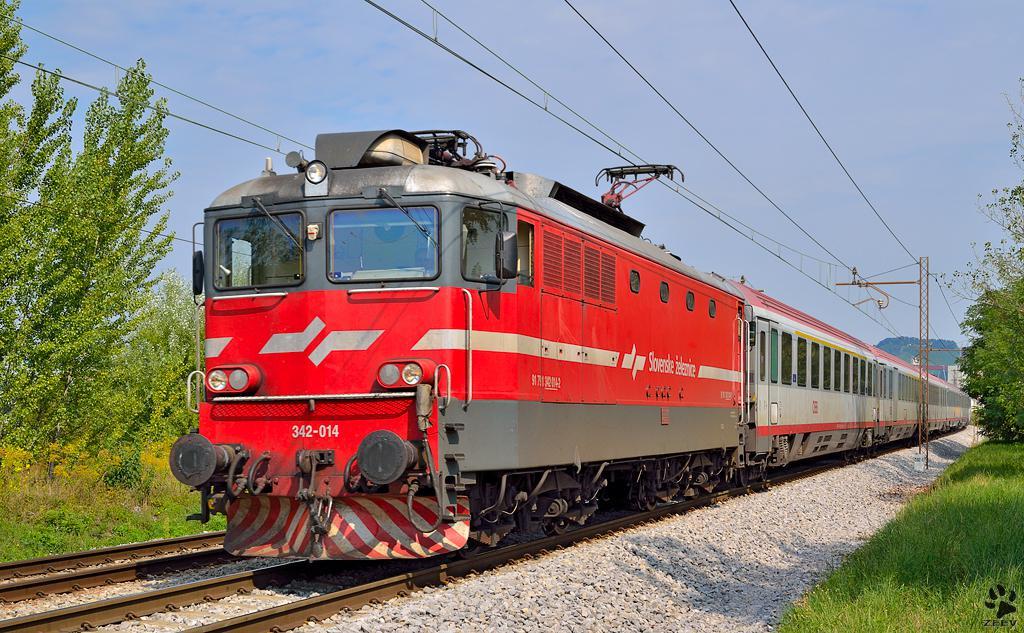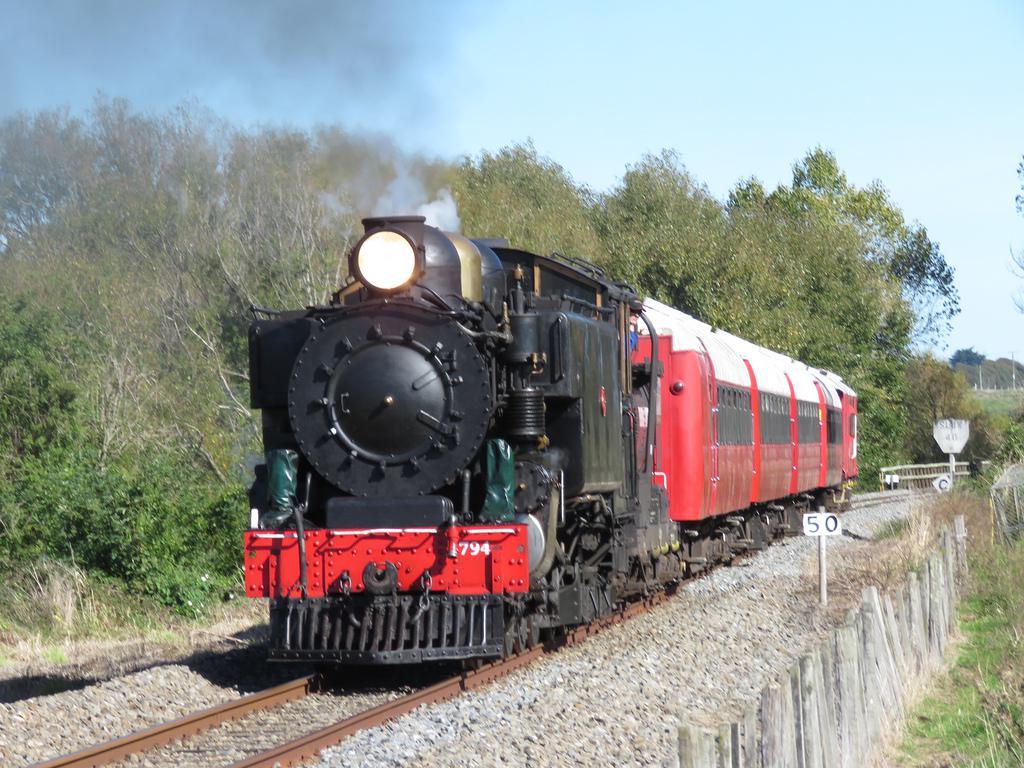The first image is the image on the left, the second image is the image on the right. Assess this claim about the two images: "The engines in both images are have some red color and are facing to the left.". Correct or not? Answer yes or no. Yes. The first image is the image on the left, the second image is the image on the right. Analyze the images presented: Is the assertion "read trains are facing the left of the image" valid? Answer yes or no. Yes. 